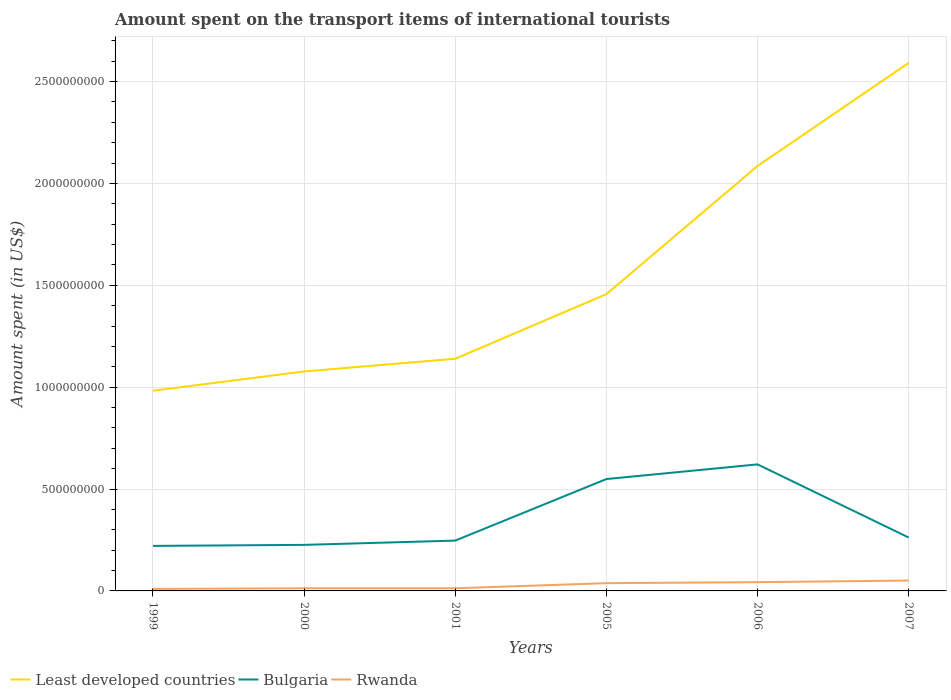Is the number of lines equal to the number of legend labels?
Give a very brief answer. Yes. Across all years, what is the maximum amount spent on the transport items of international tourists in Rwanda?
Ensure brevity in your answer.  1.00e+07. In which year was the amount spent on the transport items of international tourists in Least developed countries maximum?
Provide a succinct answer. 1999. What is the total amount spent on the transport items of international tourists in Bulgaria in the graph?
Give a very brief answer. 2.87e+08. What is the difference between the highest and the second highest amount spent on the transport items of international tourists in Least developed countries?
Your answer should be very brief. 1.61e+09. Is the amount spent on the transport items of international tourists in Rwanda strictly greater than the amount spent on the transport items of international tourists in Bulgaria over the years?
Your response must be concise. Yes. How many lines are there?
Your response must be concise. 3. How many years are there in the graph?
Your answer should be very brief. 6. Does the graph contain any zero values?
Give a very brief answer. No. Does the graph contain grids?
Your response must be concise. Yes. Where does the legend appear in the graph?
Offer a very short reply. Bottom left. How are the legend labels stacked?
Provide a succinct answer. Horizontal. What is the title of the graph?
Offer a terse response. Amount spent on the transport items of international tourists. What is the label or title of the X-axis?
Your answer should be very brief. Years. What is the label or title of the Y-axis?
Keep it short and to the point. Amount spent (in US$). What is the Amount spent (in US$) of Least developed countries in 1999?
Your response must be concise. 9.82e+08. What is the Amount spent (in US$) of Bulgaria in 1999?
Offer a terse response. 2.21e+08. What is the Amount spent (in US$) of Rwanda in 1999?
Your response must be concise. 1.00e+07. What is the Amount spent (in US$) of Least developed countries in 2000?
Offer a very short reply. 1.08e+09. What is the Amount spent (in US$) of Bulgaria in 2000?
Your answer should be compact. 2.26e+08. What is the Amount spent (in US$) of Rwanda in 2000?
Make the answer very short. 1.30e+07. What is the Amount spent (in US$) of Least developed countries in 2001?
Offer a terse response. 1.14e+09. What is the Amount spent (in US$) of Bulgaria in 2001?
Make the answer very short. 2.47e+08. What is the Amount spent (in US$) of Rwanda in 2001?
Your response must be concise. 1.30e+07. What is the Amount spent (in US$) of Least developed countries in 2005?
Your answer should be very brief. 1.46e+09. What is the Amount spent (in US$) of Bulgaria in 2005?
Your answer should be very brief. 5.49e+08. What is the Amount spent (in US$) of Rwanda in 2005?
Make the answer very short. 3.80e+07. What is the Amount spent (in US$) of Least developed countries in 2006?
Keep it short and to the point. 2.09e+09. What is the Amount spent (in US$) of Bulgaria in 2006?
Provide a succinct answer. 6.21e+08. What is the Amount spent (in US$) in Rwanda in 2006?
Provide a short and direct response. 4.30e+07. What is the Amount spent (in US$) in Least developed countries in 2007?
Give a very brief answer. 2.59e+09. What is the Amount spent (in US$) in Bulgaria in 2007?
Ensure brevity in your answer.  2.62e+08. What is the Amount spent (in US$) in Rwanda in 2007?
Your answer should be very brief. 5.10e+07. Across all years, what is the maximum Amount spent (in US$) in Least developed countries?
Your response must be concise. 2.59e+09. Across all years, what is the maximum Amount spent (in US$) in Bulgaria?
Offer a terse response. 6.21e+08. Across all years, what is the maximum Amount spent (in US$) in Rwanda?
Offer a very short reply. 5.10e+07. Across all years, what is the minimum Amount spent (in US$) in Least developed countries?
Provide a succinct answer. 9.82e+08. Across all years, what is the minimum Amount spent (in US$) in Bulgaria?
Provide a short and direct response. 2.21e+08. Across all years, what is the minimum Amount spent (in US$) in Rwanda?
Provide a succinct answer. 1.00e+07. What is the total Amount spent (in US$) of Least developed countries in the graph?
Offer a terse response. 9.33e+09. What is the total Amount spent (in US$) in Bulgaria in the graph?
Offer a terse response. 2.13e+09. What is the total Amount spent (in US$) in Rwanda in the graph?
Offer a very short reply. 1.68e+08. What is the difference between the Amount spent (in US$) in Least developed countries in 1999 and that in 2000?
Offer a very short reply. -9.45e+07. What is the difference between the Amount spent (in US$) in Bulgaria in 1999 and that in 2000?
Provide a short and direct response. -5.00e+06. What is the difference between the Amount spent (in US$) in Rwanda in 1999 and that in 2000?
Offer a terse response. -3.00e+06. What is the difference between the Amount spent (in US$) in Least developed countries in 1999 and that in 2001?
Give a very brief answer. -1.57e+08. What is the difference between the Amount spent (in US$) of Bulgaria in 1999 and that in 2001?
Your answer should be compact. -2.60e+07. What is the difference between the Amount spent (in US$) in Rwanda in 1999 and that in 2001?
Offer a terse response. -3.00e+06. What is the difference between the Amount spent (in US$) in Least developed countries in 1999 and that in 2005?
Give a very brief answer. -4.74e+08. What is the difference between the Amount spent (in US$) in Bulgaria in 1999 and that in 2005?
Provide a short and direct response. -3.28e+08. What is the difference between the Amount spent (in US$) in Rwanda in 1999 and that in 2005?
Keep it short and to the point. -2.80e+07. What is the difference between the Amount spent (in US$) of Least developed countries in 1999 and that in 2006?
Your answer should be very brief. -1.10e+09. What is the difference between the Amount spent (in US$) of Bulgaria in 1999 and that in 2006?
Offer a terse response. -4.00e+08. What is the difference between the Amount spent (in US$) in Rwanda in 1999 and that in 2006?
Make the answer very short. -3.30e+07. What is the difference between the Amount spent (in US$) in Least developed countries in 1999 and that in 2007?
Your answer should be compact. -1.61e+09. What is the difference between the Amount spent (in US$) in Bulgaria in 1999 and that in 2007?
Provide a short and direct response. -4.10e+07. What is the difference between the Amount spent (in US$) of Rwanda in 1999 and that in 2007?
Ensure brevity in your answer.  -4.10e+07. What is the difference between the Amount spent (in US$) in Least developed countries in 2000 and that in 2001?
Ensure brevity in your answer.  -6.25e+07. What is the difference between the Amount spent (in US$) of Bulgaria in 2000 and that in 2001?
Provide a short and direct response. -2.10e+07. What is the difference between the Amount spent (in US$) in Rwanda in 2000 and that in 2001?
Your response must be concise. 0. What is the difference between the Amount spent (in US$) of Least developed countries in 2000 and that in 2005?
Provide a succinct answer. -3.79e+08. What is the difference between the Amount spent (in US$) of Bulgaria in 2000 and that in 2005?
Your answer should be very brief. -3.23e+08. What is the difference between the Amount spent (in US$) in Rwanda in 2000 and that in 2005?
Your answer should be compact. -2.50e+07. What is the difference between the Amount spent (in US$) in Least developed countries in 2000 and that in 2006?
Keep it short and to the point. -1.01e+09. What is the difference between the Amount spent (in US$) in Bulgaria in 2000 and that in 2006?
Your answer should be compact. -3.95e+08. What is the difference between the Amount spent (in US$) in Rwanda in 2000 and that in 2006?
Make the answer very short. -3.00e+07. What is the difference between the Amount spent (in US$) of Least developed countries in 2000 and that in 2007?
Your answer should be compact. -1.51e+09. What is the difference between the Amount spent (in US$) of Bulgaria in 2000 and that in 2007?
Offer a very short reply. -3.60e+07. What is the difference between the Amount spent (in US$) of Rwanda in 2000 and that in 2007?
Provide a short and direct response. -3.80e+07. What is the difference between the Amount spent (in US$) of Least developed countries in 2001 and that in 2005?
Keep it short and to the point. -3.17e+08. What is the difference between the Amount spent (in US$) of Bulgaria in 2001 and that in 2005?
Give a very brief answer. -3.02e+08. What is the difference between the Amount spent (in US$) of Rwanda in 2001 and that in 2005?
Give a very brief answer. -2.50e+07. What is the difference between the Amount spent (in US$) in Least developed countries in 2001 and that in 2006?
Your answer should be very brief. -9.46e+08. What is the difference between the Amount spent (in US$) in Bulgaria in 2001 and that in 2006?
Provide a short and direct response. -3.74e+08. What is the difference between the Amount spent (in US$) of Rwanda in 2001 and that in 2006?
Provide a short and direct response. -3.00e+07. What is the difference between the Amount spent (in US$) of Least developed countries in 2001 and that in 2007?
Offer a very short reply. -1.45e+09. What is the difference between the Amount spent (in US$) in Bulgaria in 2001 and that in 2007?
Your answer should be very brief. -1.50e+07. What is the difference between the Amount spent (in US$) in Rwanda in 2001 and that in 2007?
Your response must be concise. -3.80e+07. What is the difference between the Amount spent (in US$) in Least developed countries in 2005 and that in 2006?
Ensure brevity in your answer.  -6.29e+08. What is the difference between the Amount spent (in US$) in Bulgaria in 2005 and that in 2006?
Keep it short and to the point. -7.20e+07. What is the difference between the Amount spent (in US$) in Rwanda in 2005 and that in 2006?
Your response must be concise. -5.00e+06. What is the difference between the Amount spent (in US$) of Least developed countries in 2005 and that in 2007?
Your response must be concise. -1.13e+09. What is the difference between the Amount spent (in US$) of Bulgaria in 2005 and that in 2007?
Ensure brevity in your answer.  2.87e+08. What is the difference between the Amount spent (in US$) in Rwanda in 2005 and that in 2007?
Ensure brevity in your answer.  -1.30e+07. What is the difference between the Amount spent (in US$) of Least developed countries in 2006 and that in 2007?
Make the answer very short. -5.06e+08. What is the difference between the Amount spent (in US$) of Bulgaria in 2006 and that in 2007?
Make the answer very short. 3.59e+08. What is the difference between the Amount spent (in US$) of Rwanda in 2006 and that in 2007?
Offer a very short reply. -8.00e+06. What is the difference between the Amount spent (in US$) of Least developed countries in 1999 and the Amount spent (in US$) of Bulgaria in 2000?
Provide a short and direct response. 7.56e+08. What is the difference between the Amount spent (in US$) in Least developed countries in 1999 and the Amount spent (in US$) in Rwanda in 2000?
Ensure brevity in your answer.  9.69e+08. What is the difference between the Amount spent (in US$) in Bulgaria in 1999 and the Amount spent (in US$) in Rwanda in 2000?
Your response must be concise. 2.08e+08. What is the difference between the Amount spent (in US$) in Least developed countries in 1999 and the Amount spent (in US$) in Bulgaria in 2001?
Offer a terse response. 7.35e+08. What is the difference between the Amount spent (in US$) in Least developed countries in 1999 and the Amount spent (in US$) in Rwanda in 2001?
Your answer should be very brief. 9.69e+08. What is the difference between the Amount spent (in US$) in Bulgaria in 1999 and the Amount spent (in US$) in Rwanda in 2001?
Give a very brief answer. 2.08e+08. What is the difference between the Amount spent (in US$) of Least developed countries in 1999 and the Amount spent (in US$) of Bulgaria in 2005?
Provide a succinct answer. 4.33e+08. What is the difference between the Amount spent (in US$) of Least developed countries in 1999 and the Amount spent (in US$) of Rwanda in 2005?
Your answer should be very brief. 9.44e+08. What is the difference between the Amount spent (in US$) in Bulgaria in 1999 and the Amount spent (in US$) in Rwanda in 2005?
Keep it short and to the point. 1.83e+08. What is the difference between the Amount spent (in US$) in Least developed countries in 1999 and the Amount spent (in US$) in Bulgaria in 2006?
Keep it short and to the point. 3.61e+08. What is the difference between the Amount spent (in US$) of Least developed countries in 1999 and the Amount spent (in US$) of Rwanda in 2006?
Your answer should be compact. 9.39e+08. What is the difference between the Amount spent (in US$) of Bulgaria in 1999 and the Amount spent (in US$) of Rwanda in 2006?
Your answer should be very brief. 1.78e+08. What is the difference between the Amount spent (in US$) of Least developed countries in 1999 and the Amount spent (in US$) of Bulgaria in 2007?
Offer a very short reply. 7.20e+08. What is the difference between the Amount spent (in US$) in Least developed countries in 1999 and the Amount spent (in US$) in Rwanda in 2007?
Make the answer very short. 9.31e+08. What is the difference between the Amount spent (in US$) in Bulgaria in 1999 and the Amount spent (in US$) in Rwanda in 2007?
Make the answer very short. 1.70e+08. What is the difference between the Amount spent (in US$) of Least developed countries in 2000 and the Amount spent (in US$) of Bulgaria in 2001?
Ensure brevity in your answer.  8.30e+08. What is the difference between the Amount spent (in US$) of Least developed countries in 2000 and the Amount spent (in US$) of Rwanda in 2001?
Provide a short and direct response. 1.06e+09. What is the difference between the Amount spent (in US$) in Bulgaria in 2000 and the Amount spent (in US$) in Rwanda in 2001?
Ensure brevity in your answer.  2.13e+08. What is the difference between the Amount spent (in US$) in Least developed countries in 2000 and the Amount spent (in US$) in Bulgaria in 2005?
Your answer should be compact. 5.28e+08. What is the difference between the Amount spent (in US$) in Least developed countries in 2000 and the Amount spent (in US$) in Rwanda in 2005?
Ensure brevity in your answer.  1.04e+09. What is the difference between the Amount spent (in US$) of Bulgaria in 2000 and the Amount spent (in US$) of Rwanda in 2005?
Provide a succinct answer. 1.88e+08. What is the difference between the Amount spent (in US$) of Least developed countries in 2000 and the Amount spent (in US$) of Bulgaria in 2006?
Your answer should be compact. 4.56e+08. What is the difference between the Amount spent (in US$) in Least developed countries in 2000 and the Amount spent (in US$) in Rwanda in 2006?
Keep it short and to the point. 1.03e+09. What is the difference between the Amount spent (in US$) in Bulgaria in 2000 and the Amount spent (in US$) in Rwanda in 2006?
Ensure brevity in your answer.  1.83e+08. What is the difference between the Amount spent (in US$) of Least developed countries in 2000 and the Amount spent (in US$) of Bulgaria in 2007?
Ensure brevity in your answer.  8.15e+08. What is the difference between the Amount spent (in US$) in Least developed countries in 2000 and the Amount spent (in US$) in Rwanda in 2007?
Ensure brevity in your answer.  1.03e+09. What is the difference between the Amount spent (in US$) of Bulgaria in 2000 and the Amount spent (in US$) of Rwanda in 2007?
Give a very brief answer. 1.75e+08. What is the difference between the Amount spent (in US$) of Least developed countries in 2001 and the Amount spent (in US$) of Bulgaria in 2005?
Give a very brief answer. 5.90e+08. What is the difference between the Amount spent (in US$) of Least developed countries in 2001 and the Amount spent (in US$) of Rwanda in 2005?
Your response must be concise. 1.10e+09. What is the difference between the Amount spent (in US$) in Bulgaria in 2001 and the Amount spent (in US$) in Rwanda in 2005?
Keep it short and to the point. 2.09e+08. What is the difference between the Amount spent (in US$) of Least developed countries in 2001 and the Amount spent (in US$) of Bulgaria in 2006?
Your answer should be compact. 5.18e+08. What is the difference between the Amount spent (in US$) in Least developed countries in 2001 and the Amount spent (in US$) in Rwanda in 2006?
Ensure brevity in your answer.  1.10e+09. What is the difference between the Amount spent (in US$) of Bulgaria in 2001 and the Amount spent (in US$) of Rwanda in 2006?
Your answer should be compact. 2.04e+08. What is the difference between the Amount spent (in US$) of Least developed countries in 2001 and the Amount spent (in US$) of Bulgaria in 2007?
Make the answer very short. 8.77e+08. What is the difference between the Amount spent (in US$) in Least developed countries in 2001 and the Amount spent (in US$) in Rwanda in 2007?
Ensure brevity in your answer.  1.09e+09. What is the difference between the Amount spent (in US$) in Bulgaria in 2001 and the Amount spent (in US$) in Rwanda in 2007?
Give a very brief answer. 1.96e+08. What is the difference between the Amount spent (in US$) of Least developed countries in 2005 and the Amount spent (in US$) of Bulgaria in 2006?
Your answer should be compact. 8.35e+08. What is the difference between the Amount spent (in US$) in Least developed countries in 2005 and the Amount spent (in US$) in Rwanda in 2006?
Offer a terse response. 1.41e+09. What is the difference between the Amount spent (in US$) of Bulgaria in 2005 and the Amount spent (in US$) of Rwanda in 2006?
Your answer should be very brief. 5.06e+08. What is the difference between the Amount spent (in US$) in Least developed countries in 2005 and the Amount spent (in US$) in Bulgaria in 2007?
Provide a short and direct response. 1.19e+09. What is the difference between the Amount spent (in US$) of Least developed countries in 2005 and the Amount spent (in US$) of Rwanda in 2007?
Your answer should be very brief. 1.41e+09. What is the difference between the Amount spent (in US$) in Bulgaria in 2005 and the Amount spent (in US$) in Rwanda in 2007?
Make the answer very short. 4.98e+08. What is the difference between the Amount spent (in US$) of Least developed countries in 2006 and the Amount spent (in US$) of Bulgaria in 2007?
Make the answer very short. 1.82e+09. What is the difference between the Amount spent (in US$) of Least developed countries in 2006 and the Amount spent (in US$) of Rwanda in 2007?
Your answer should be very brief. 2.03e+09. What is the difference between the Amount spent (in US$) of Bulgaria in 2006 and the Amount spent (in US$) of Rwanda in 2007?
Offer a terse response. 5.70e+08. What is the average Amount spent (in US$) in Least developed countries per year?
Offer a terse response. 1.56e+09. What is the average Amount spent (in US$) of Bulgaria per year?
Provide a short and direct response. 3.54e+08. What is the average Amount spent (in US$) in Rwanda per year?
Ensure brevity in your answer.  2.80e+07. In the year 1999, what is the difference between the Amount spent (in US$) of Least developed countries and Amount spent (in US$) of Bulgaria?
Ensure brevity in your answer.  7.61e+08. In the year 1999, what is the difference between the Amount spent (in US$) of Least developed countries and Amount spent (in US$) of Rwanda?
Your answer should be very brief. 9.72e+08. In the year 1999, what is the difference between the Amount spent (in US$) of Bulgaria and Amount spent (in US$) of Rwanda?
Ensure brevity in your answer.  2.11e+08. In the year 2000, what is the difference between the Amount spent (in US$) in Least developed countries and Amount spent (in US$) in Bulgaria?
Your answer should be very brief. 8.51e+08. In the year 2000, what is the difference between the Amount spent (in US$) in Least developed countries and Amount spent (in US$) in Rwanda?
Make the answer very short. 1.06e+09. In the year 2000, what is the difference between the Amount spent (in US$) of Bulgaria and Amount spent (in US$) of Rwanda?
Provide a succinct answer. 2.13e+08. In the year 2001, what is the difference between the Amount spent (in US$) of Least developed countries and Amount spent (in US$) of Bulgaria?
Your answer should be compact. 8.92e+08. In the year 2001, what is the difference between the Amount spent (in US$) in Least developed countries and Amount spent (in US$) in Rwanda?
Your response must be concise. 1.13e+09. In the year 2001, what is the difference between the Amount spent (in US$) of Bulgaria and Amount spent (in US$) of Rwanda?
Keep it short and to the point. 2.34e+08. In the year 2005, what is the difference between the Amount spent (in US$) in Least developed countries and Amount spent (in US$) in Bulgaria?
Give a very brief answer. 9.07e+08. In the year 2005, what is the difference between the Amount spent (in US$) in Least developed countries and Amount spent (in US$) in Rwanda?
Give a very brief answer. 1.42e+09. In the year 2005, what is the difference between the Amount spent (in US$) in Bulgaria and Amount spent (in US$) in Rwanda?
Keep it short and to the point. 5.11e+08. In the year 2006, what is the difference between the Amount spent (in US$) in Least developed countries and Amount spent (in US$) in Bulgaria?
Offer a very short reply. 1.46e+09. In the year 2006, what is the difference between the Amount spent (in US$) of Least developed countries and Amount spent (in US$) of Rwanda?
Offer a very short reply. 2.04e+09. In the year 2006, what is the difference between the Amount spent (in US$) in Bulgaria and Amount spent (in US$) in Rwanda?
Your response must be concise. 5.78e+08. In the year 2007, what is the difference between the Amount spent (in US$) of Least developed countries and Amount spent (in US$) of Bulgaria?
Keep it short and to the point. 2.33e+09. In the year 2007, what is the difference between the Amount spent (in US$) of Least developed countries and Amount spent (in US$) of Rwanda?
Make the answer very short. 2.54e+09. In the year 2007, what is the difference between the Amount spent (in US$) in Bulgaria and Amount spent (in US$) in Rwanda?
Your response must be concise. 2.11e+08. What is the ratio of the Amount spent (in US$) in Least developed countries in 1999 to that in 2000?
Give a very brief answer. 0.91. What is the ratio of the Amount spent (in US$) of Bulgaria in 1999 to that in 2000?
Your answer should be compact. 0.98. What is the ratio of the Amount spent (in US$) of Rwanda in 1999 to that in 2000?
Give a very brief answer. 0.77. What is the ratio of the Amount spent (in US$) of Least developed countries in 1999 to that in 2001?
Give a very brief answer. 0.86. What is the ratio of the Amount spent (in US$) in Bulgaria in 1999 to that in 2001?
Offer a very short reply. 0.89. What is the ratio of the Amount spent (in US$) of Rwanda in 1999 to that in 2001?
Provide a succinct answer. 0.77. What is the ratio of the Amount spent (in US$) in Least developed countries in 1999 to that in 2005?
Your answer should be very brief. 0.67. What is the ratio of the Amount spent (in US$) in Bulgaria in 1999 to that in 2005?
Your answer should be compact. 0.4. What is the ratio of the Amount spent (in US$) in Rwanda in 1999 to that in 2005?
Offer a terse response. 0.26. What is the ratio of the Amount spent (in US$) of Least developed countries in 1999 to that in 2006?
Keep it short and to the point. 0.47. What is the ratio of the Amount spent (in US$) in Bulgaria in 1999 to that in 2006?
Offer a very short reply. 0.36. What is the ratio of the Amount spent (in US$) of Rwanda in 1999 to that in 2006?
Your response must be concise. 0.23. What is the ratio of the Amount spent (in US$) of Least developed countries in 1999 to that in 2007?
Provide a short and direct response. 0.38. What is the ratio of the Amount spent (in US$) of Bulgaria in 1999 to that in 2007?
Make the answer very short. 0.84. What is the ratio of the Amount spent (in US$) in Rwanda in 1999 to that in 2007?
Offer a very short reply. 0.2. What is the ratio of the Amount spent (in US$) in Least developed countries in 2000 to that in 2001?
Ensure brevity in your answer.  0.95. What is the ratio of the Amount spent (in US$) in Bulgaria in 2000 to that in 2001?
Offer a very short reply. 0.92. What is the ratio of the Amount spent (in US$) in Rwanda in 2000 to that in 2001?
Give a very brief answer. 1. What is the ratio of the Amount spent (in US$) of Least developed countries in 2000 to that in 2005?
Give a very brief answer. 0.74. What is the ratio of the Amount spent (in US$) of Bulgaria in 2000 to that in 2005?
Make the answer very short. 0.41. What is the ratio of the Amount spent (in US$) of Rwanda in 2000 to that in 2005?
Make the answer very short. 0.34. What is the ratio of the Amount spent (in US$) in Least developed countries in 2000 to that in 2006?
Make the answer very short. 0.52. What is the ratio of the Amount spent (in US$) in Bulgaria in 2000 to that in 2006?
Offer a terse response. 0.36. What is the ratio of the Amount spent (in US$) in Rwanda in 2000 to that in 2006?
Offer a terse response. 0.3. What is the ratio of the Amount spent (in US$) in Least developed countries in 2000 to that in 2007?
Ensure brevity in your answer.  0.42. What is the ratio of the Amount spent (in US$) in Bulgaria in 2000 to that in 2007?
Make the answer very short. 0.86. What is the ratio of the Amount spent (in US$) of Rwanda in 2000 to that in 2007?
Your answer should be compact. 0.25. What is the ratio of the Amount spent (in US$) of Least developed countries in 2001 to that in 2005?
Your answer should be very brief. 0.78. What is the ratio of the Amount spent (in US$) of Bulgaria in 2001 to that in 2005?
Offer a terse response. 0.45. What is the ratio of the Amount spent (in US$) of Rwanda in 2001 to that in 2005?
Your answer should be very brief. 0.34. What is the ratio of the Amount spent (in US$) of Least developed countries in 2001 to that in 2006?
Provide a short and direct response. 0.55. What is the ratio of the Amount spent (in US$) in Bulgaria in 2001 to that in 2006?
Your answer should be compact. 0.4. What is the ratio of the Amount spent (in US$) in Rwanda in 2001 to that in 2006?
Keep it short and to the point. 0.3. What is the ratio of the Amount spent (in US$) of Least developed countries in 2001 to that in 2007?
Offer a very short reply. 0.44. What is the ratio of the Amount spent (in US$) in Bulgaria in 2001 to that in 2007?
Make the answer very short. 0.94. What is the ratio of the Amount spent (in US$) of Rwanda in 2001 to that in 2007?
Provide a short and direct response. 0.25. What is the ratio of the Amount spent (in US$) of Least developed countries in 2005 to that in 2006?
Give a very brief answer. 0.7. What is the ratio of the Amount spent (in US$) in Bulgaria in 2005 to that in 2006?
Provide a succinct answer. 0.88. What is the ratio of the Amount spent (in US$) of Rwanda in 2005 to that in 2006?
Keep it short and to the point. 0.88. What is the ratio of the Amount spent (in US$) of Least developed countries in 2005 to that in 2007?
Offer a terse response. 0.56. What is the ratio of the Amount spent (in US$) in Bulgaria in 2005 to that in 2007?
Give a very brief answer. 2.1. What is the ratio of the Amount spent (in US$) of Rwanda in 2005 to that in 2007?
Your answer should be very brief. 0.75. What is the ratio of the Amount spent (in US$) in Least developed countries in 2006 to that in 2007?
Your response must be concise. 0.8. What is the ratio of the Amount spent (in US$) in Bulgaria in 2006 to that in 2007?
Keep it short and to the point. 2.37. What is the ratio of the Amount spent (in US$) in Rwanda in 2006 to that in 2007?
Provide a succinct answer. 0.84. What is the difference between the highest and the second highest Amount spent (in US$) in Least developed countries?
Give a very brief answer. 5.06e+08. What is the difference between the highest and the second highest Amount spent (in US$) of Bulgaria?
Keep it short and to the point. 7.20e+07. What is the difference between the highest and the lowest Amount spent (in US$) of Least developed countries?
Make the answer very short. 1.61e+09. What is the difference between the highest and the lowest Amount spent (in US$) in Bulgaria?
Give a very brief answer. 4.00e+08. What is the difference between the highest and the lowest Amount spent (in US$) in Rwanda?
Your answer should be compact. 4.10e+07. 